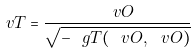<formula> <loc_0><loc_0><loc_500><loc_500>\ v T = \frac { \ v O } { \sqrt { - \ g T ( \ v O , \ v O ) } }</formula> 